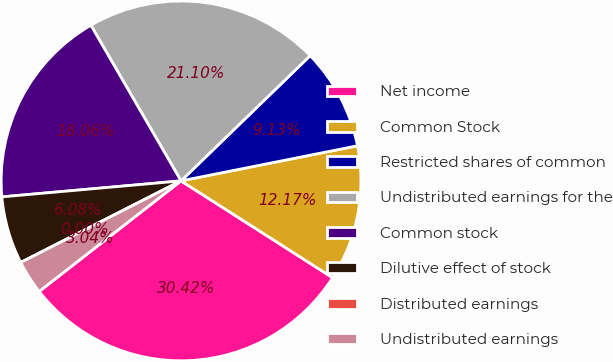Convert chart. <chart><loc_0><loc_0><loc_500><loc_500><pie_chart><fcel>Net income<fcel>Common Stock<fcel>Restricted shares of common<fcel>Undistributed earnings for the<fcel>Common stock<fcel>Dilutive effect of stock<fcel>Distributed earnings<fcel>Undistributed earnings<nl><fcel>30.42%<fcel>12.17%<fcel>9.13%<fcel>21.1%<fcel>18.06%<fcel>6.08%<fcel>0.0%<fcel>3.04%<nl></chart> 